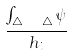<formula> <loc_0><loc_0><loc_500><loc_500>\frac { \int _ { \triangle _ { h _ { i } } \ \triangle } \psi } { h _ { i } }</formula> 